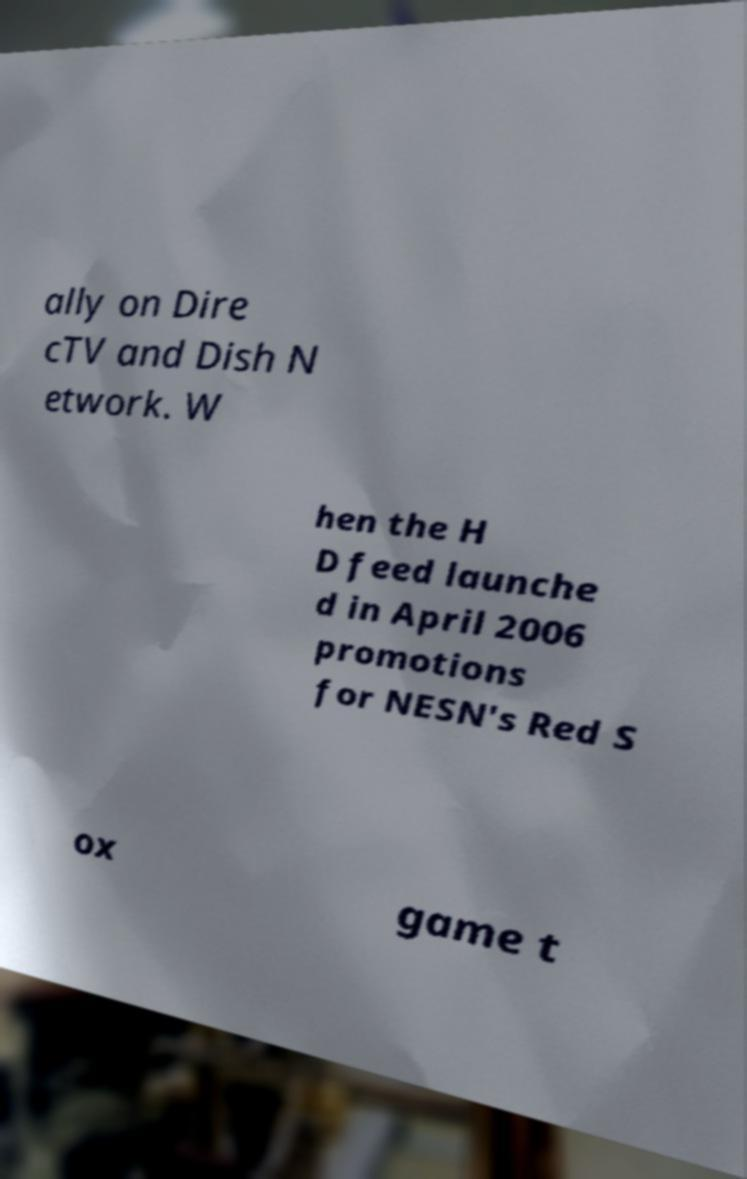Can you accurately transcribe the text from the provided image for me? ally on Dire cTV and Dish N etwork. W hen the H D feed launche d in April 2006 promotions for NESN's Red S ox game t 